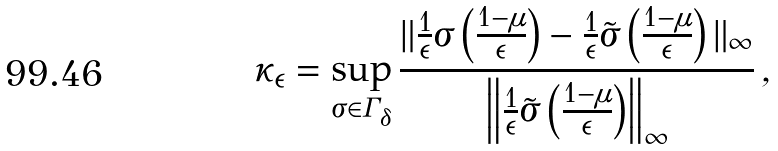Convert formula to latex. <formula><loc_0><loc_0><loc_500><loc_500>\kappa _ { \epsilon } = \sup _ { \sigma \in \Gamma _ { \delta } } \frac { \| \frac { 1 } { \epsilon } \sigma \left ( \frac { 1 - \mu } { \epsilon } \right ) - \frac { 1 } { \epsilon } \tilde { \sigma } \left ( \frac { 1 - \mu } { \epsilon } \right ) \| _ { \infty } } { \left \| \frac { 1 } { \epsilon } \tilde { \sigma } \left ( \frac { 1 - \mu } { \epsilon } \right ) \right \| _ { \infty } } \, ,</formula> 